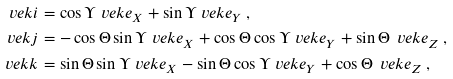Convert formula to latex. <formula><loc_0><loc_0><loc_500><loc_500>\ v e k { i } & = \cos \Upsilon \ v e k { e } _ { X } + \sin \Upsilon \ v e k { e } _ { Y } \, , \\ \ v e k { j } & = - \cos \Theta \sin \Upsilon \ v e k { e } _ { X } + \cos \Theta \cos \Upsilon \ v e k { e } _ { Y } + \sin \Theta \, \ v e k { e } _ { Z } \, , \\ \ v e k { k } & = \sin \Theta \sin \Upsilon \ v e k { e } _ { X } - \sin \Theta \cos \Upsilon \ v e k { e } _ { Y } + \cos \Theta \, \ v e k { e } _ { Z } \, ,</formula> 